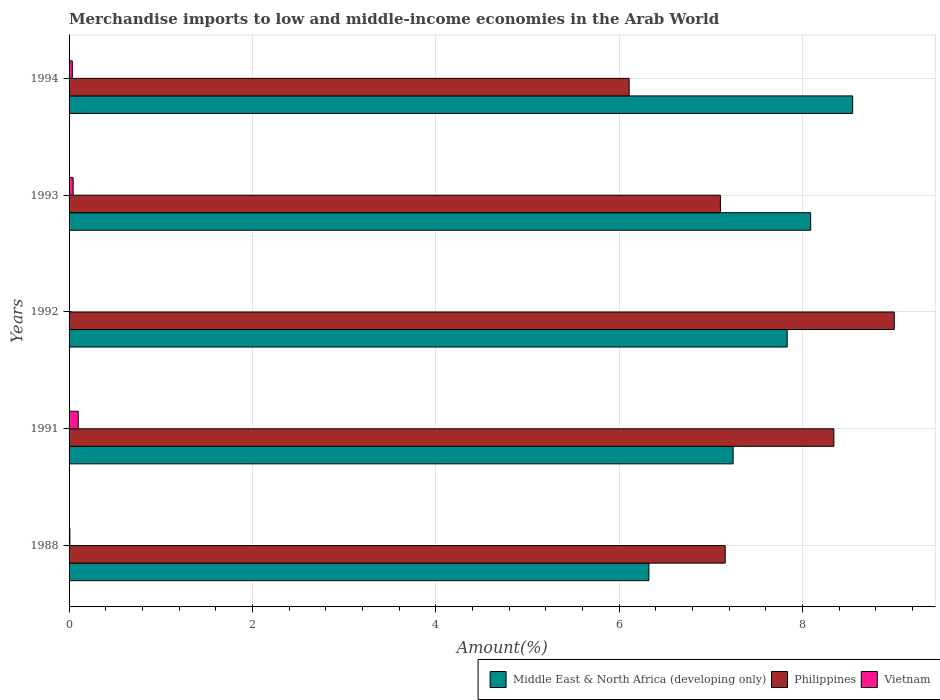Are the number of bars on each tick of the Y-axis equal?
Your answer should be very brief. Yes. How many bars are there on the 5th tick from the top?
Offer a terse response. 3. In how many cases, is the number of bars for a given year not equal to the number of legend labels?
Offer a very short reply. 0. What is the percentage of amount earned from merchandise imports in Middle East & North Africa (developing only) in 1988?
Provide a short and direct response. 6.33. Across all years, what is the maximum percentage of amount earned from merchandise imports in Middle East & North Africa (developing only)?
Ensure brevity in your answer.  8.55. Across all years, what is the minimum percentage of amount earned from merchandise imports in Vietnam?
Your answer should be very brief. 0. What is the total percentage of amount earned from merchandise imports in Middle East & North Africa (developing only) in the graph?
Your answer should be very brief. 38.04. What is the difference between the percentage of amount earned from merchandise imports in Middle East & North Africa (developing only) in 1988 and that in 1994?
Your answer should be very brief. -2.22. What is the difference between the percentage of amount earned from merchandise imports in Philippines in 1993 and the percentage of amount earned from merchandise imports in Middle East & North Africa (developing only) in 1988?
Provide a short and direct response. 0.78. What is the average percentage of amount earned from merchandise imports in Philippines per year?
Keep it short and to the point. 7.54. In the year 1988, what is the difference between the percentage of amount earned from merchandise imports in Philippines and percentage of amount earned from merchandise imports in Middle East & North Africa (developing only)?
Your answer should be compact. 0.83. In how many years, is the percentage of amount earned from merchandise imports in Philippines greater than 6.8 %?
Provide a short and direct response. 4. What is the ratio of the percentage of amount earned from merchandise imports in Vietnam in 1991 to that in 1994?
Ensure brevity in your answer.  2.83. Is the difference between the percentage of amount earned from merchandise imports in Philippines in 1988 and 1994 greater than the difference between the percentage of amount earned from merchandise imports in Middle East & North Africa (developing only) in 1988 and 1994?
Your answer should be compact. Yes. What is the difference between the highest and the second highest percentage of amount earned from merchandise imports in Vietnam?
Give a very brief answer. 0.06. What is the difference between the highest and the lowest percentage of amount earned from merchandise imports in Philippines?
Your answer should be very brief. 2.89. Is the sum of the percentage of amount earned from merchandise imports in Vietnam in 1988 and 1991 greater than the maximum percentage of amount earned from merchandise imports in Middle East & North Africa (developing only) across all years?
Ensure brevity in your answer.  No. What does the 3rd bar from the top in 1988 represents?
Give a very brief answer. Middle East & North Africa (developing only). Is it the case that in every year, the sum of the percentage of amount earned from merchandise imports in Philippines and percentage of amount earned from merchandise imports in Vietnam is greater than the percentage of amount earned from merchandise imports in Middle East & North Africa (developing only)?
Your answer should be very brief. No. How many bars are there?
Provide a succinct answer. 15. What is the difference between two consecutive major ticks on the X-axis?
Offer a terse response. 2. Does the graph contain any zero values?
Make the answer very short. No. Does the graph contain grids?
Your answer should be compact. Yes. How are the legend labels stacked?
Your answer should be very brief. Horizontal. What is the title of the graph?
Ensure brevity in your answer.  Merchandise imports to low and middle-income economies in the Arab World. Does "Tonga" appear as one of the legend labels in the graph?
Give a very brief answer. No. What is the label or title of the X-axis?
Offer a very short reply. Amount(%). What is the label or title of the Y-axis?
Make the answer very short. Years. What is the Amount(%) in Middle East & North Africa (developing only) in 1988?
Your answer should be compact. 6.33. What is the Amount(%) of Philippines in 1988?
Keep it short and to the point. 7.16. What is the Amount(%) in Vietnam in 1988?
Give a very brief answer. 0.01. What is the Amount(%) in Middle East & North Africa (developing only) in 1991?
Make the answer very short. 7.24. What is the Amount(%) of Philippines in 1991?
Provide a short and direct response. 8.34. What is the Amount(%) of Vietnam in 1991?
Make the answer very short. 0.1. What is the Amount(%) of Middle East & North Africa (developing only) in 1992?
Provide a succinct answer. 7.83. What is the Amount(%) of Philippines in 1992?
Keep it short and to the point. 9. What is the Amount(%) of Vietnam in 1992?
Your response must be concise. 0. What is the Amount(%) of Middle East & North Africa (developing only) in 1993?
Keep it short and to the point. 8.09. What is the Amount(%) in Philippines in 1993?
Your answer should be compact. 7.11. What is the Amount(%) of Vietnam in 1993?
Give a very brief answer. 0.04. What is the Amount(%) in Middle East & North Africa (developing only) in 1994?
Keep it short and to the point. 8.55. What is the Amount(%) in Philippines in 1994?
Provide a succinct answer. 6.11. What is the Amount(%) in Vietnam in 1994?
Ensure brevity in your answer.  0.04. Across all years, what is the maximum Amount(%) of Middle East & North Africa (developing only)?
Provide a short and direct response. 8.55. Across all years, what is the maximum Amount(%) of Philippines?
Make the answer very short. 9. Across all years, what is the maximum Amount(%) of Vietnam?
Offer a very short reply. 0.1. Across all years, what is the minimum Amount(%) in Middle East & North Africa (developing only)?
Make the answer very short. 6.33. Across all years, what is the minimum Amount(%) in Philippines?
Your answer should be very brief. 6.11. Across all years, what is the minimum Amount(%) of Vietnam?
Provide a short and direct response. 0. What is the total Amount(%) in Middle East & North Africa (developing only) in the graph?
Keep it short and to the point. 38.04. What is the total Amount(%) in Philippines in the graph?
Make the answer very short. 37.72. What is the total Amount(%) in Vietnam in the graph?
Give a very brief answer. 0.19. What is the difference between the Amount(%) in Middle East & North Africa (developing only) in 1988 and that in 1991?
Provide a succinct answer. -0.92. What is the difference between the Amount(%) of Philippines in 1988 and that in 1991?
Your answer should be compact. -1.19. What is the difference between the Amount(%) in Vietnam in 1988 and that in 1991?
Keep it short and to the point. -0.09. What is the difference between the Amount(%) in Middle East & North Africa (developing only) in 1988 and that in 1992?
Make the answer very short. -1.51. What is the difference between the Amount(%) of Philippines in 1988 and that in 1992?
Your answer should be compact. -1.84. What is the difference between the Amount(%) of Vietnam in 1988 and that in 1992?
Ensure brevity in your answer.  0.01. What is the difference between the Amount(%) of Middle East & North Africa (developing only) in 1988 and that in 1993?
Offer a very short reply. -1.76. What is the difference between the Amount(%) in Philippines in 1988 and that in 1993?
Your answer should be very brief. 0.05. What is the difference between the Amount(%) of Vietnam in 1988 and that in 1993?
Give a very brief answer. -0.04. What is the difference between the Amount(%) of Middle East & North Africa (developing only) in 1988 and that in 1994?
Offer a very short reply. -2.22. What is the difference between the Amount(%) in Philippines in 1988 and that in 1994?
Provide a succinct answer. 1.05. What is the difference between the Amount(%) in Vietnam in 1988 and that in 1994?
Ensure brevity in your answer.  -0.03. What is the difference between the Amount(%) in Middle East & North Africa (developing only) in 1991 and that in 1992?
Your response must be concise. -0.59. What is the difference between the Amount(%) of Philippines in 1991 and that in 1992?
Keep it short and to the point. -0.66. What is the difference between the Amount(%) of Vietnam in 1991 and that in 1992?
Your response must be concise. 0.1. What is the difference between the Amount(%) of Middle East & North Africa (developing only) in 1991 and that in 1993?
Offer a very short reply. -0.85. What is the difference between the Amount(%) of Philippines in 1991 and that in 1993?
Ensure brevity in your answer.  1.24. What is the difference between the Amount(%) in Vietnam in 1991 and that in 1993?
Provide a succinct answer. 0.06. What is the difference between the Amount(%) of Middle East & North Africa (developing only) in 1991 and that in 1994?
Your answer should be compact. -1.3. What is the difference between the Amount(%) of Philippines in 1991 and that in 1994?
Your answer should be compact. 2.23. What is the difference between the Amount(%) of Vietnam in 1991 and that in 1994?
Provide a succinct answer. 0.06. What is the difference between the Amount(%) of Middle East & North Africa (developing only) in 1992 and that in 1993?
Offer a terse response. -0.26. What is the difference between the Amount(%) in Philippines in 1992 and that in 1993?
Ensure brevity in your answer.  1.9. What is the difference between the Amount(%) in Vietnam in 1992 and that in 1993?
Ensure brevity in your answer.  -0.04. What is the difference between the Amount(%) in Middle East & North Africa (developing only) in 1992 and that in 1994?
Your answer should be very brief. -0.71. What is the difference between the Amount(%) in Philippines in 1992 and that in 1994?
Keep it short and to the point. 2.89. What is the difference between the Amount(%) in Vietnam in 1992 and that in 1994?
Your response must be concise. -0.04. What is the difference between the Amount(%) in Middle East & North Africa (developing only) in 1993 and that in 1994?
Make the answer very short. -0.46. What is the difference between the Amount(%) of Philippines in 1993 and that in 1994?
Your answer should be compact. 1. What is the difference between the Amount(%) in Vietnam in 1993 and that in 1994?
Provide a succinct answer. 0.01. What is the difference between the Amount(%) in Middle East & North Africa (developing only) in 1988 and the Amount(%) in Philippines in 1991?
Keep it short and to the point. -2.02. What is the difference between the Amount(%) of Middle East & North Africa (developing only) in 1988 and the Amount(%) of Vietnam in 1991?
Make the answer very short. 6.23. What is the difference between the Amount(%) of Philippines in 1988 and the Amount(%) of Vietnam in 1991?
Your answer should be compact. 7.06. What is the difference between the Amount(%) of Middle East & North Africa (developing only) in 1988 and the Amount(%) of Philippines in 1992?
Offer a very short reply. -2.68. What is the difference between the Amount(%) of Middle East & North Africa (developing only) in 1988 and the Amount(%) of Vietnam in 1992?
Offer a terse response. 6.33. What is the difference between the Amount(%) of Philippines in 1988 and the Amount(%) of Vietnam in 1992?
Keep it short and to the point. 7.16. What is the difference between the Amount(%) of Middle East & North Africa (developing only) in 1988 and the Amount(%) of Philippines in 1993?
Provide a short and direct response. -0.78. What is the difference between the Amount(%) in Middle East & North Africa (developing only) in 1988 and the Amount(%) in Vietnam in 1993?
Make the answer very short. 6.28. What is the difference between the Amount(%) of Philippines in 1988 and the Amount(%) of Vietnam in 1993?
Ensure brevity in your answer.  7.11. What is the difference between the Amount(%) of Middle East & North Africa (developing only) in 1988 and the Amount(%) of Philippines in 1994?
Your answer should be compact. 0.22. What is the difference between the Amount(%) of Middle East & North Africa (developing only) in 1988 and the Amount(%) of Vietnam in 1994?
Ensure brevity in your answer.  6.29. What is the difference between the Amount(%) of Philippines in 1988 and the Amount(%) of Vietnam in 1994?
Provide a short and direct response. 7.12. What is the difference between the Amount(%) of Middle East & North Africa (developing only) in 1991 and the Amount(%) of Philippines in 1992?
Your answer should be very brief. -1.76. What is the difference between the Amount(%) in Middle East & North Africa (developing only) in 1991 and the Amount(%) in Vietnam in 1992?
Make the answer very short. 7.24. What is the difference between the Amount(%) of Philippines in 1991 and the Amount(%) of Vietnam in 1992?
Keep it short and to the point. 8.34. What is the difference between the Amount(%) of Middle East & North Africa (developing only) in 1991 and the Amount(%) of Philippines in 1993?
Provide a succinct answer. 0.14. What is the difference between the Amount(%) of Middle East & North Africa (developing only) in 1991 and the Amount(%) of Vietnam in 1993?
Offer a terse response. 7.2. What is the difference between the Amount(%) of Philippines in 1991 and the Amount(%) of Vietnam in 1993?
Your answer should be very brief. 8.3. What is the difference between the Amount(%) of Middle East & North Africa (developing only) in 1991 and the Amount(%) of Philippines in 1994?
Your response must be concise. 1.13. What is the difference between the Amount(%) of Middle East & North Africa (developing only) in 1991 and the Amount(%) of Vietnam in 1994?
Your answer should be compact. 7.21. What is the difference between the Amount(%) of Philippines in 1991 and the Amount(%) of Vietnam in 1994?
Offer a terse response. 8.31. What is the difference between the Amount(%) in Middle East & North Africa (developing only) in 1992 and the Amount(%) in Philippines in 1993?
Your response must be concise. 0.73. What is the difference between the Amount(%) in Middle East & North Africa (developing only) in 1992 and the Amount(%) in Vietnam in 1993?
Ensure brevity in your answer.  7.79. What is the difference between the Amount(%) in Philippines in 1992 and the Amount(%) in Vietnam in 1993?
Provide a succinct answer. 8.96. What is the difference between the Amount(%) in Middle East & North Africa (developing only) in 1992 and the Amount(%) in Philippines in 1994?
Offer a terse response. 1.72. What is the difference between the Amount(%) in Middle East & North Africa (developing only) in 1992 and the Amount(%) in Vietnam in 1994?
Keep it short and to the point. 7.8. What is the difference between the Amount(%) in Philippines in 1992 and the Amount(%) in Vietnam in 1994?
Give a very brief answer. 8.97. What is the difference between the Amount(%) in Middle East & North Africa (developing only) in 1993 and the Amount(%) in Philippines in 1994?
Your answer should be very brief. 1.98. What is the difference between the Amount(%) in Middle East & North Africa (developing only) in 1993 and the Amount(%) in Vietnam in 1994?
Your answer should be compact. 8.05. What is the difference between the Amount(%) of Philippines in 1993 and the Amount(%) of Vietnam in 1994?
Provide a short and direct response. 7.07. What is the average Amount(%) of Middle East & North Africa (developing only) per year?
Give a very brief answer. 7.61. What is the average Amount(%) of Philippines per year?
Provide a short and direct response. 7.54. What is the average Amount(%) of Vietnam per year?
Ensure brevity in your answer.  0.04. In the year 1988, what is the difference between the Amount(%) of Middle East & North Africa (developing only) and Amount(%) of Philippines?
Offer a very short reply. -0.83. In the year 1988, what is the difference between the Amount(%) of Middle East & North Africa (developing only) and Amount(%) of Vietnam?
Your answer should be compact. 6.32. In the year 1988, what is the difference between the Amount(%) of Philippines and Amount(%) of Vietnam?
Provide a succinct answer. 7.15. In the year 1991, what is the difference between the Amount(%) in Middle East & North Africa (developing only) and Amount(%) in Philippines?
Provide a succinct answer. -1.1. In the year 1991, what is the difference between the Amount(%) in Middle East & North Africa (developing only) and Amount(%) in Vietnam?
Make the answer very short. 7.14. In the year 1991, what is the difference between the Amount(%) in Philippines and Amount(%) in Vietnam?
Ensure brevity in your answer.  8.24. In the year 1992, what is the difference between the Amount(%) of Middle East & North Africa (developing only) and Amount(%) of Philippines?
Ensure brevity in your answer.  -1.17. In the year 1992, what is the difference between the Amount(%) of Middle East & North Africa (developing only) and Amount(%) of Vietnam?
Offer a very short reply. 7.83. In the year 1992, what is the difference between the Amount(%) of Philippines and Amount(%) of Vietnam?
Make the answer very short. 9. In the year 1993, what is the difference between the Amount(%) of Middle East & North Africa (developing only) and Amount(%) of Philippines?
Ensure brevity in your answer.  0.98. In the year 1993, what is the difference between the Amount(%) of Middle East & North Africa (developing only) and Amount(%) of Vietnam?
Provide a succinct answer. 8.05. In the year 1993, what is the difference between the Amount(%) in Philippines and Amount(%) in Vietnam?
Offer a terse response. 7.06. In the year 1994, what is the difference between the Amount(%) in Middle East & North Africa (developing only) and Amount(%) in Philippines?
Your answer should be very brief. 2.44. In the year 1994, what is the difference between the Amount(%) of Middle East & North Africa (developing only) and Amount(%) of Vietnam?
Your answer should be compact. 8.51. In the year 1994, what is the difference between the Amount(%) of Philippines and Amount(%) of Vietnam?
Ensure brevity in your answer.  6.07. What is the ratio of the Amount(%) in Middle East & North Africa (developing only) in 1988 to that in 1991?
Provide a short and direct response. 0.87. What is the ratio of the Amount(%) of Philippines in 1988 to that in 1991?
Provide a short and direct response. 0.86. What is the ratio of the Amount(%) of Vietnam in 1988 to that in 1991?
Provide a short and direct response. 0.09. What is the ratio of the Amount(%) of Middle East & North Africa (developing only) in 1988 to that in 1992?
Make the answer very short. 0.81. What is the ratio of the Amount(%) in Philippines in 1988 to that in 1992?
Your answer should be very brief. 0.8. What is the ratio of the Amount(%) of Vietnam in 1988 to that in 1992?
Keep it short and to the point. 52.93. What is the ratio of the Amount(%) in Middle East & North Africa (developing only) in 1988 to that in 1993?
Your answer should be compact. 0.78. What is the ratio of the Amount(%) of Philippines in 1988 to that in 1993?
Provide a short and direct response. 1.01. What is the ratio of the Amount(%) in Vietnam in 1988 to that in 1993?
Your response must be concise. 0.2. What is the ratio of the Amount(%) in Middle East & North Africa (developing only) in 1988 to that in 1994?
Give a very brief answer. 0.74. What is the ratio of the Amount(%) of Philippines in 1988 to that in 1994?
Give a very brief answer. 1.17. What is the ratio of the Amount(%) of Vietnam in 1988 to that in 1994?
Your response must be concise. 0.25. What is the ratio of the Amount(%) of Middle East & North Africa (developing only) in 1991 to that in 1992?
Provide a short and direct response. 0.92. What is the ratio of the Amount(%) of Philippines in 1991 to that in 1992?
Your response must be concise. 0.93. What is the ratio of the Amount(%) in Vietnam in 1991 to that in 1992?
Provide a short and direct response. 603.53. What is the ratio of the Amount(%) of Middle East & North Africa (developing only) in 1991 to that in 1993?
Make the answer very short. 0.9. What is the ratio of the Amount(%) of Philippines in 1991 to that in 1993?
Offer a very short reply. 1.17. What is the ratio of the Amount(%) in Vietnam in 1991 to that in 1993?
Your answer should be very brief. 2.25. What is the ratio of the Amount(%) in Middle East & North Africa (developing only) in 1991 to that in 1994?
Your answer should be compact. 0.85. What is the ratio of the Amount(%) of Philippines in 1991 to that in 1994?
Make the answer very short. 1.37. What is the ratio of the Amount(%) of Vietnam in 1991 to that in 1994?
Your response must be concise. 2.83. What is the ratio of the Amount(%) of Middle East & North Africa (developing only) in 1992 to that in 1993?
Provide a succinct answer. 0.97. What is the ratio of the Amount(%) in Philippines in 1992 to that in 1993?
Offer a terse response. 1.27. What is the ratio of the Amount(%) in Vietnam in 1992 to that in 1993?
Your answer should be very brief. 0. What is the ratio of the Amount(%) in Middle East & North Africa (developing only) in 1992 to that in 1994?
Your answer should be compact. 0.92. What is the ratio of the Amount(%) of Philippines in 1992 to that in 1994?
Make the answer very short. 1.47. What is the ratio of the Amount(%) of Vietnam in 1992 to that in 1994?
Offer a very short reply. 0. What is the ratio of the Amount(%) of Middle East & North Africa (developing only) in 1993 to that in 1994?
Make the answer very short. 0.95. What is the ratio of the Amount(%) of Philippines in 1993 to that in 1994?
Offer a terse response. 1.16. What is the ratio of the Amount(%) of Vietnam in 1993 to that in 1994?
Offer a terse response. 1.26. What is the difference between the highest and the second highest Amount(%) in Middle East & North Africa (developing only)?
Give a very brief answer. 0.46. What is the difference between the highest and the second highest Amount(%) of Philippines?
Your answer should be very brief. 0.66. What is the difference between the highest and the second highest Amount(%) of Vietnam?
Provide a short and direct response. 0.06. What is the difference between the highest and the lowest Amount(%) in Middle East & North Africa (developing only)?
Your answer should be very brief. 2.22. What is the difference between the highest and the lowest Amount(%) of Philippines?
Provide a succinct answer. 2.89. What is the difference between the highest and the lowest Amount(%) in Vietnam?
Give a very brief answer. 0.1. 